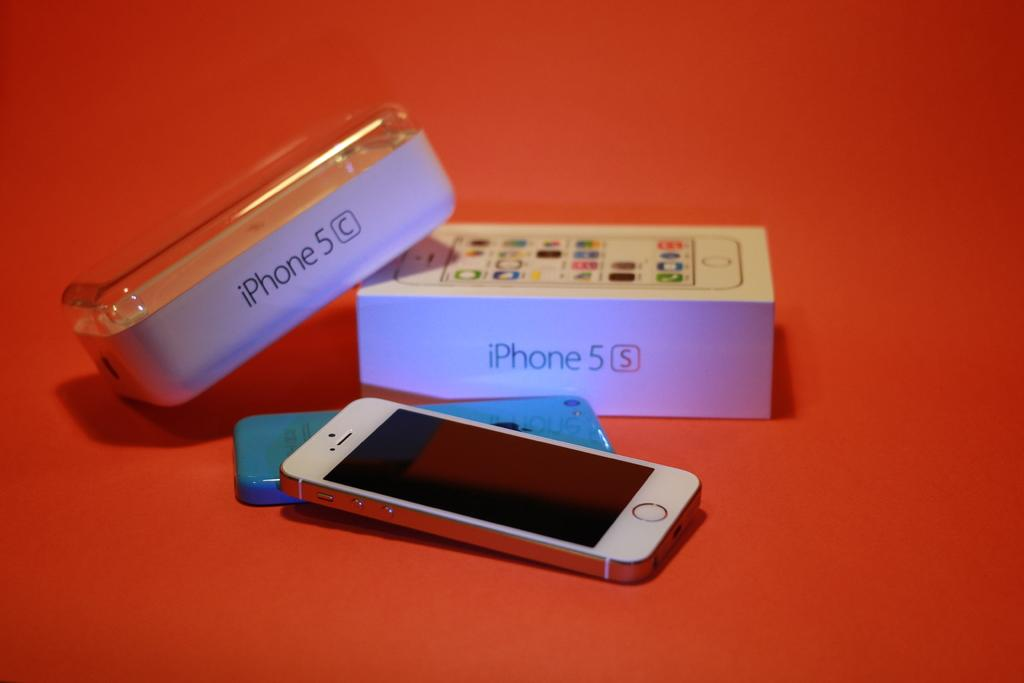<image>
Render a clear and concise summary of the photo. An iphone, a plastic case and an iphone 5C box are all sitting out next to one another. 